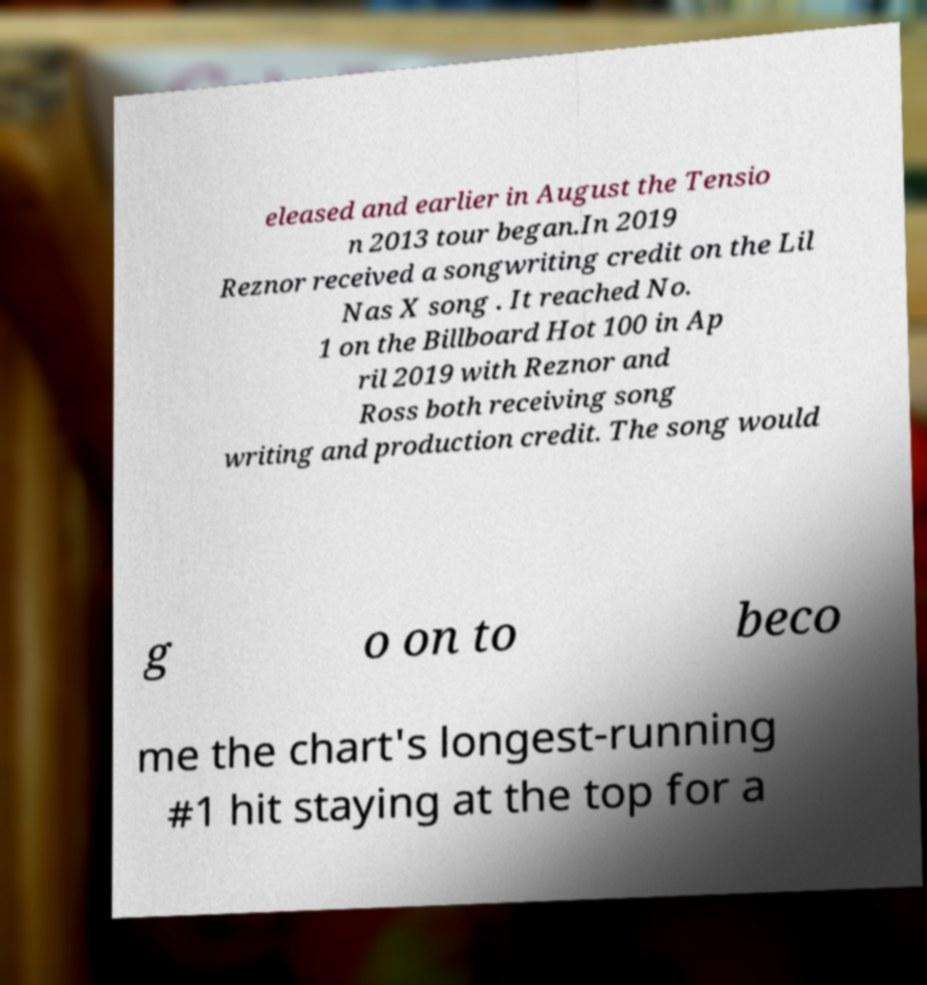Please identify and transcribe the text found in this image. eleased and earlier in August the Tensio n 2013 tour began.In 2019 Reznor received a songwriting credit on the Lil Nas X song . It reached No. 1 on the Billboard Hot 100 in Ap ril 2019 with Reznor and Ross both receiving song writing and production credit. The song would g o on to beco me the chart's longest-running #1 hit staying at the top for a 